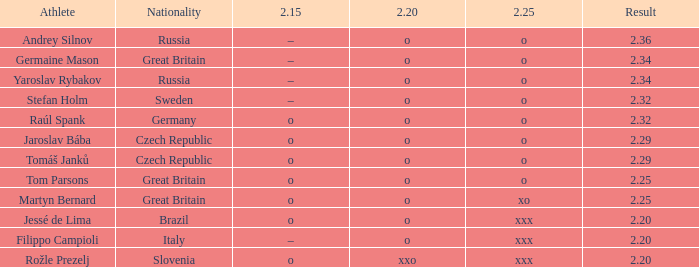25 of o? Raúl Spank. 